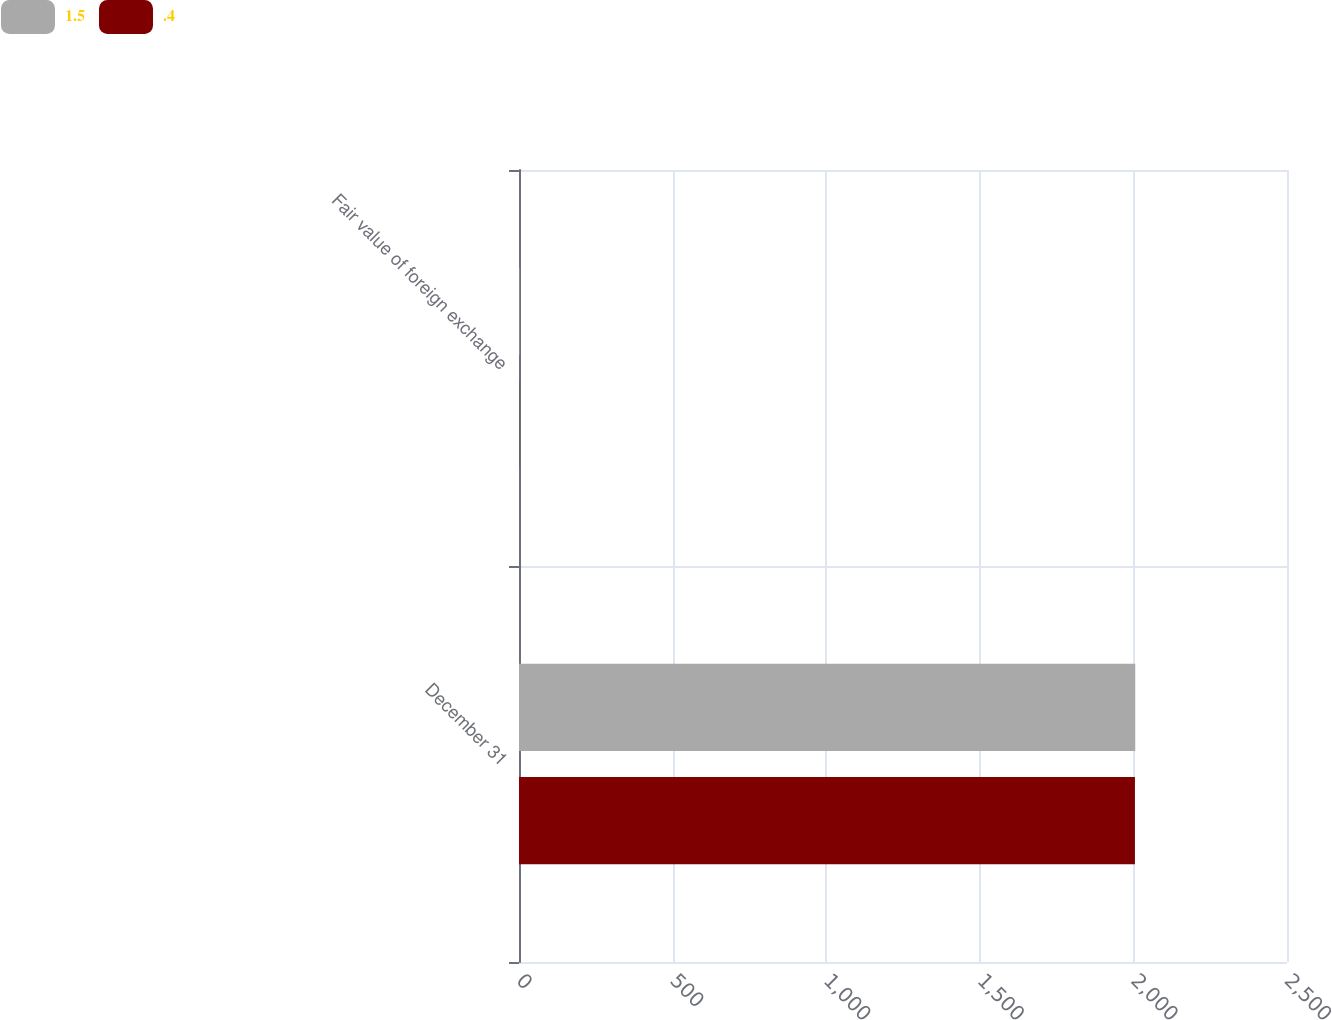Convert chart. <chart><loc_0><loc_0><loc_500><loc_500><stacked_bar_chart><ecel><fcel>December 31<fcel>Fair value of foreign exchange<nl><fcel>1.5<fcel>2006<fcel>1.5<nl><fcel>0.4<fcel>2005<fcel>0.4<nl></chart> 